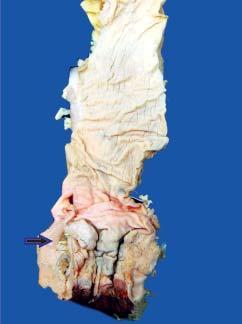s the apex grey-white and fleshy due to infiltration by the tumour?
Answer the question using a single word or phrase. No 